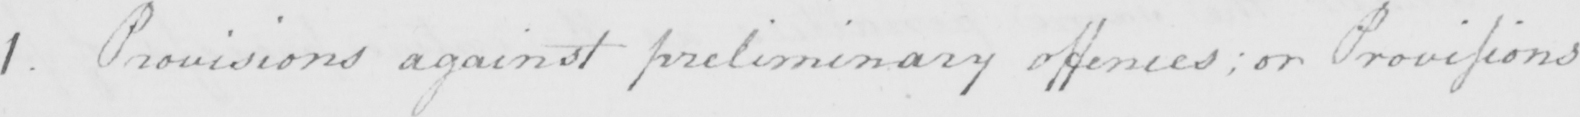What does this handwritten line say? 1 . Provisions against preliminary offences ; or Provisions 